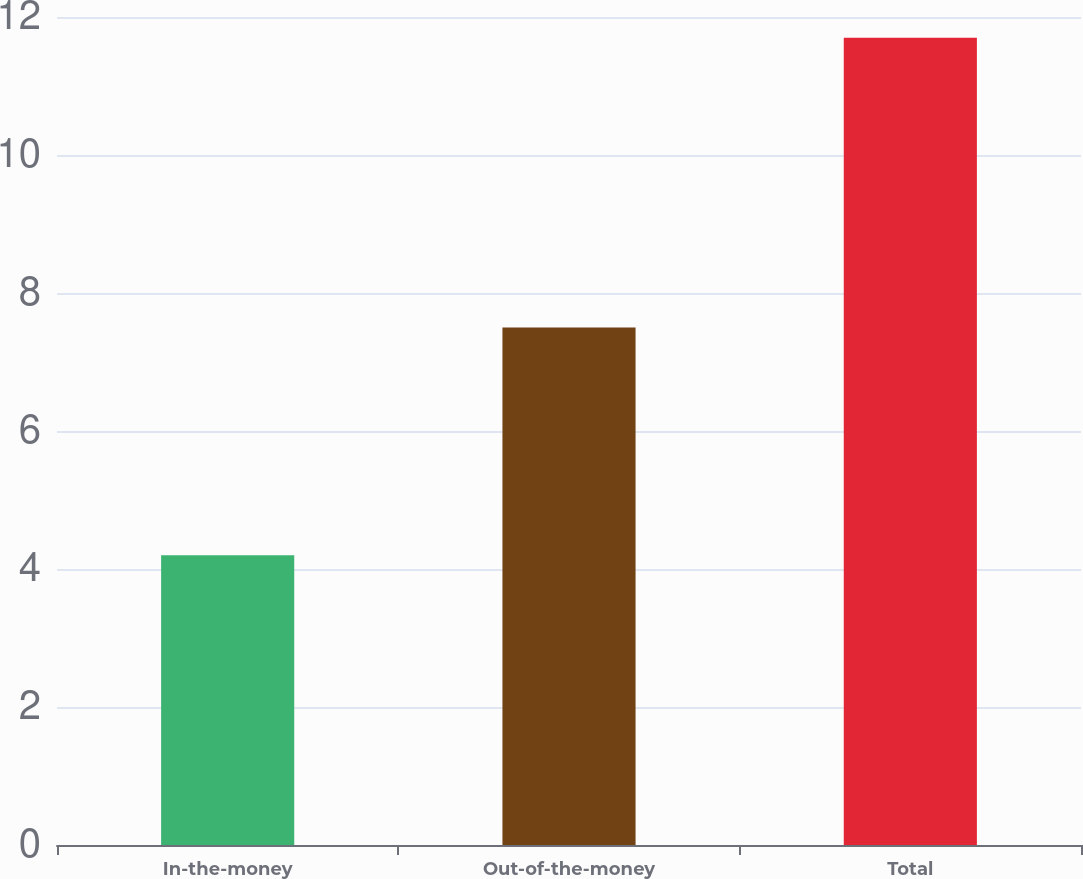Convert chart to OTSL. <chart><loc_0><loc_0><loc_500><loc_500><bar_chart><fcel>In-the-money<fcel>Out-of-the-money<fcel>Total<nl><fcel>4.2<fcel>7.5<fcel>11.7<nl></chart> 